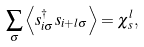Convert formula to latex. <formula><loc_0><loc_0><loc_500><loc_500>\sum _ { \sigma } \left \langle s _ { i \sigma } ^ { \dagger } s _ { i + l \sigma } \right \rangle = \chi _ { s } ^ { l } ,</formula> 